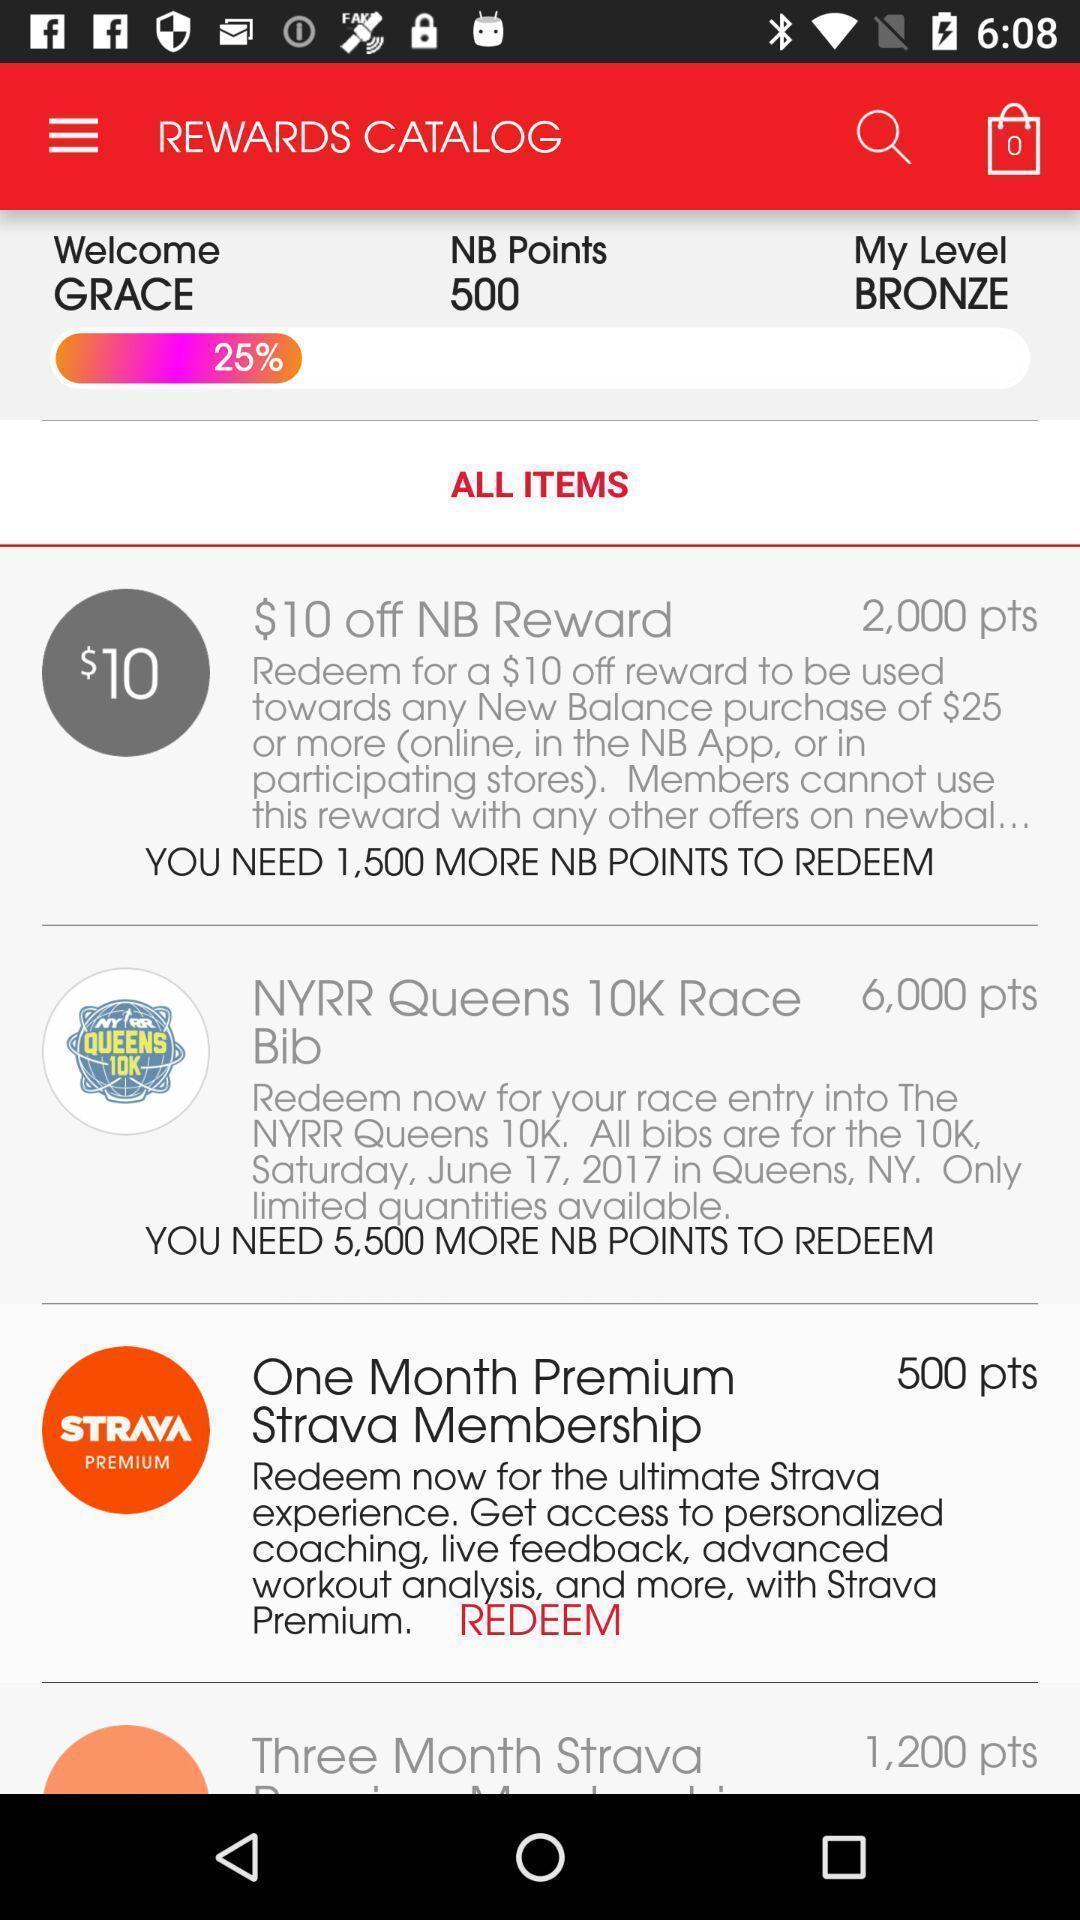Describe this image in words. Page displaying various information. 